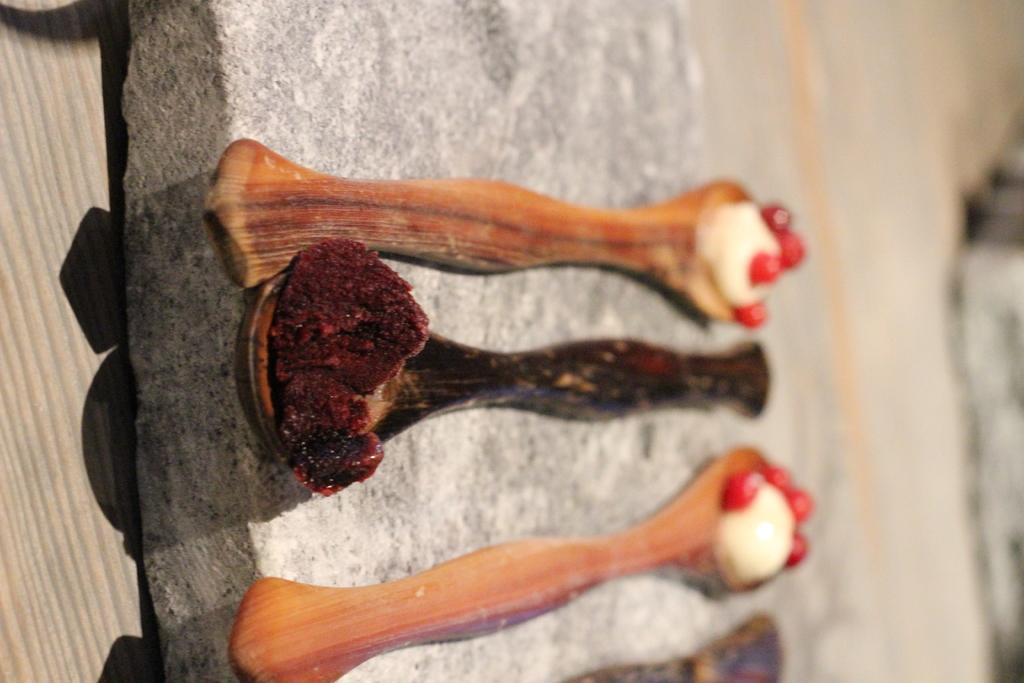What type of utensils are visible in the image? There are wooden spoons in the image. What are the wooden spoons holding? There is a food item on the wooden spoons. What type of prose can be seen on the wooden spoons? There is no prose present on the wooden spoons in the image. How many rings are visible on the food item on the wooden spoons? There are no rings visible on the food item on the wooden spoons in the image. 